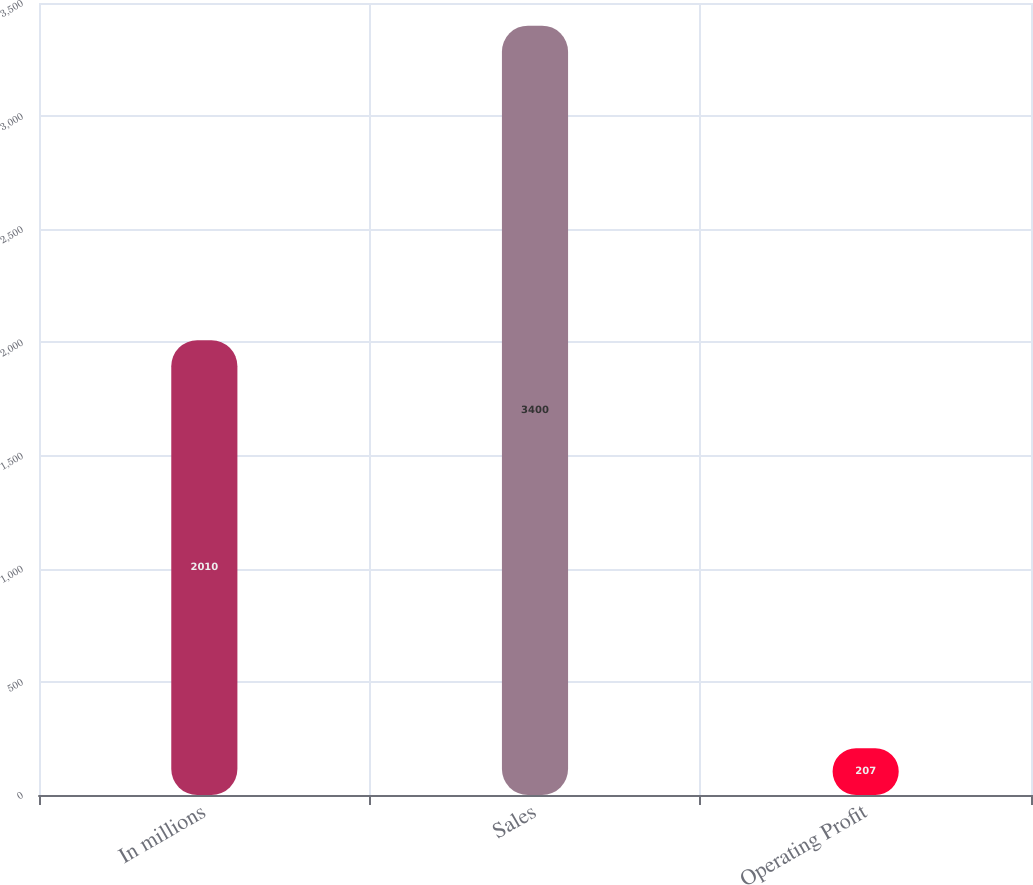Convert chart to OTSL. <chart><loc_0><loc_0><loc_500><loc_500><bar_chart><fcel>In millions<fcel>Sales<fcel>Operating Profit<nl><fcel>2010<fcel>3400<fcel>207<nl></chart> 